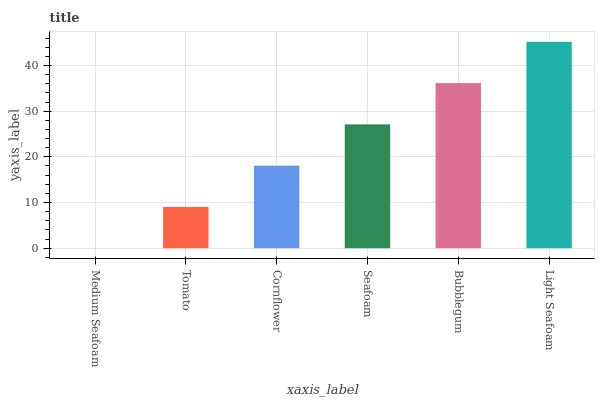Is Medium Seafoam the minimum?
Answer yes or no. Yes. Is Light Seafoam the maximum?
Answer yes or no. Yes. Is Tomato the minimum?
Answer yes or no. No. Is Tomato the maximum?
Answer yes or no. No. Is Tomato greater than Medium Seafoam?
Answer yes or no. Yes. Is Medium Seafoam less than Tomato?
Answer yes or no. Yes. Is Medium Seafoam greater than Tomato?
Answer yes or no. No. Is Tomato less than Medium Seafoam?
Answer yes or no. No. Is Seafoam the high median?
Answer yes or no. Yes. Is Cornflower the low median?
Answer yes or no. Yes. Is Medium Seafoam the high median?
Answer yes or no. No. Is Light Seafoam the low median?
Answer yes or no. No. 